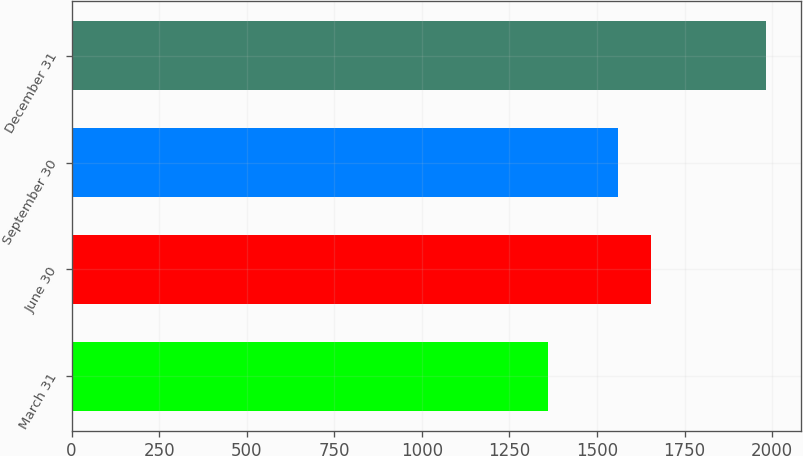<chart> <loc_0><loc_0><loc_500><loc_500><bar_chart><fcel>March 31<fcel>June 30<fcel>September 30<fcel>December 31<nl><fcel>1359.1<fcel>1652.7<fcel>1559.9<fcel>1982.5<nl></chart> 